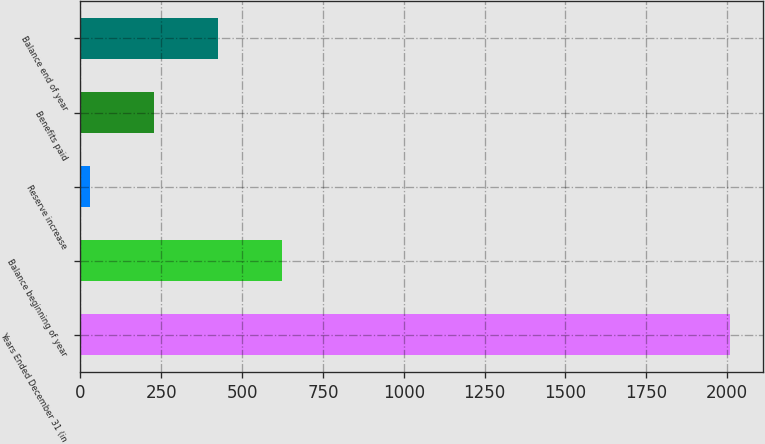Convert chart to OTSL. <chart><loc_0><loc_0><loc_500><loc_500><bar_chart><fcel>Years Ended December 31 (in<fcel>Balance beginning of year<fcel>Reserve increase<fcel>Benefits paid<fcel>Balance end of year<nl><fcel>2010<fcel>624.7<fcel>31<fcel>228.9<fcel>426.8<nl></chart> 